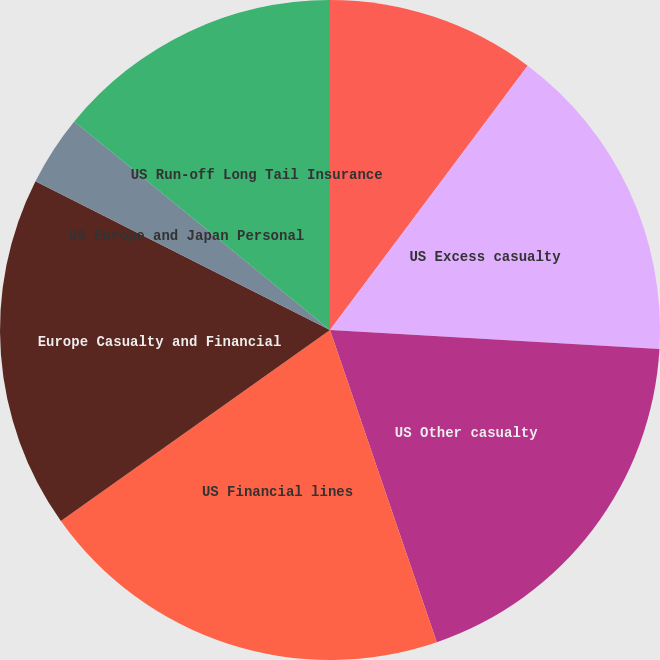Convert chart to OTSL. <chart><loc_0><loc_0><loc_500><loc_500><pie_chart><fcel>US Workers' compensation<fcel>US Excess casualty<fcel>US Other casualty<fcel>US Financial lines<fcel>Europe Casualty and Financial<fcel>US Europe and Japan Personal<fcel>US Run-off Long Tail Insurance<nl><fcel>10.22%<fcel>15.69%<fcel>18.84%<fcel>20.42%<fcel>17.27%<fcel>3.44%<fcel>14.11%<nl></chart> 